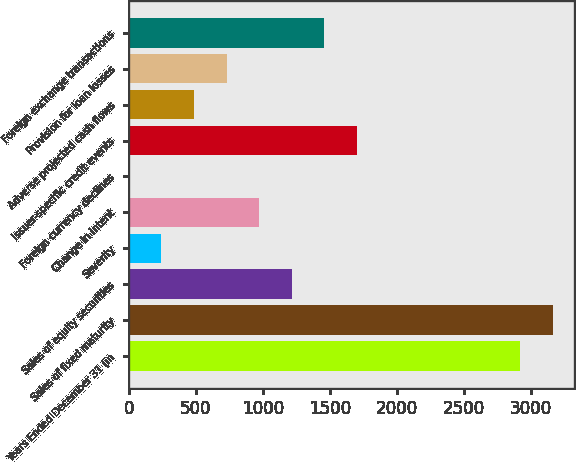Convert chart. <chart><loc_0><loc_0><loc_500><loc_500><bar_chart><fcel>Years Ended December 31 (in<fcel>Sales of fixed maturity<fcel>Sales of equity securities<fcel>Severity<fcel>Change in intent<fcel>Foreign currency declines<fcel>Issuer-specific credit events<fcel>Adverse projected cash flows<fcel>Provision for loan losses<fcel>Foreign exchange transactions<nl><fcel>2918.2<fcel>3161.3<fcel>1216.5<fcel>244.1<fcel>973.4<fcel>1<fcel>1702.7<fcel>487.2<fcel>730.3<fcel>1459.6<nl></chart> 